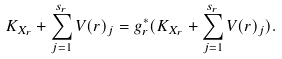Convert formula to latex. <formula><loc_0><loc_0><loc_500><loc_500>K _ { X _ { r } } + \sum _ { j = 1 } ^ { s _ { r } } V ( r ) _ { j } = g _ { r } ^ { * } ( K _ { X _ { r } } + \sum _ { j = 1 } ^ { s _ { r } } V ( r ) _ { j } ) .</formula> 